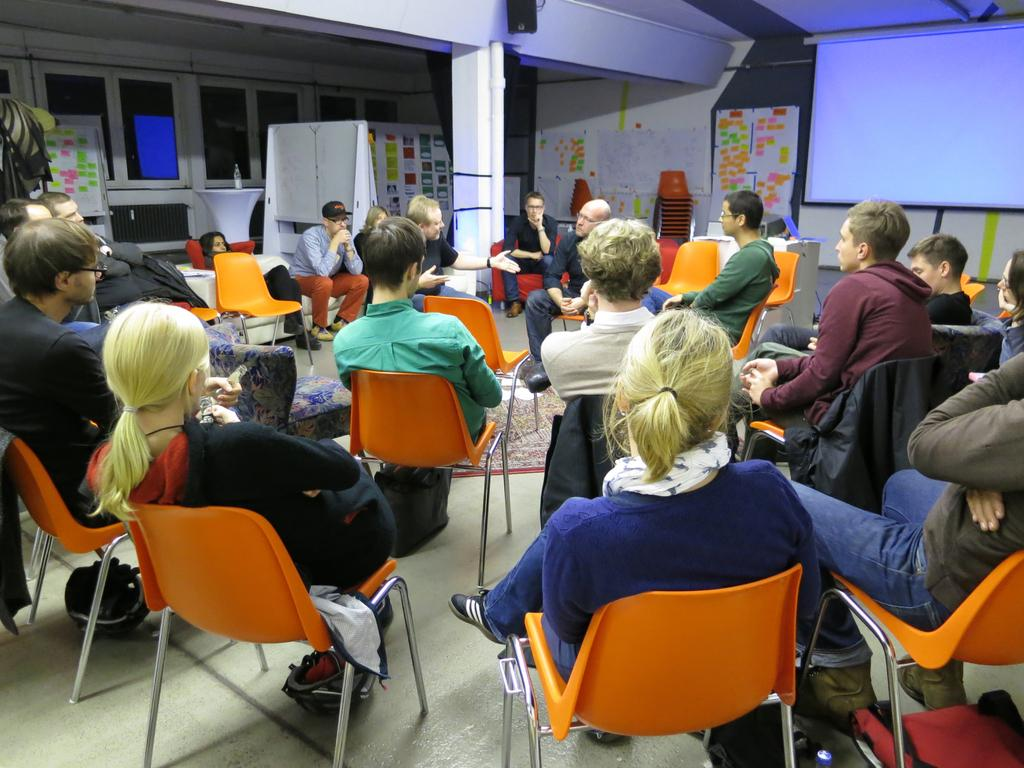What are the people in the image doing? The people in the image are sitting on chairs. What can be seen on the screen in the image? The facts do not provide information about what is on the screen. What is visible through the windows in the image? The facts do not specify what can be seen through the windows. What type of kettle is being used by the creator in the image? There is no creator or kettle present in the image. 